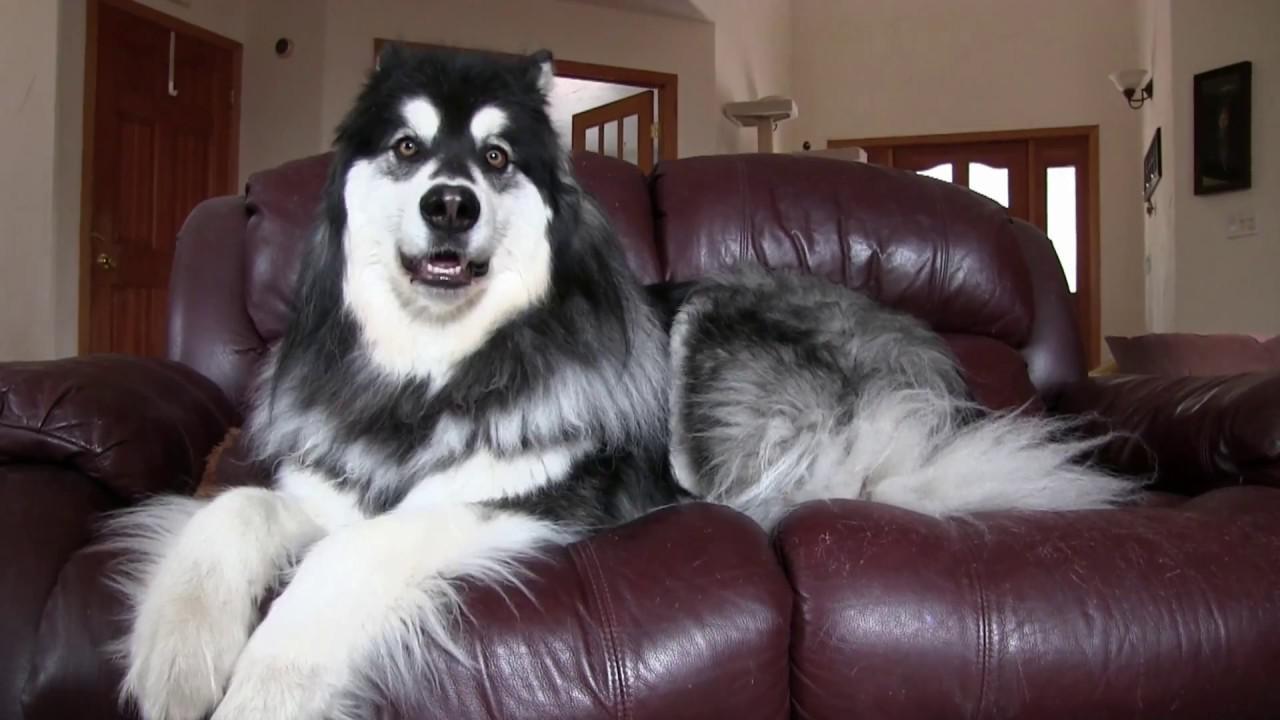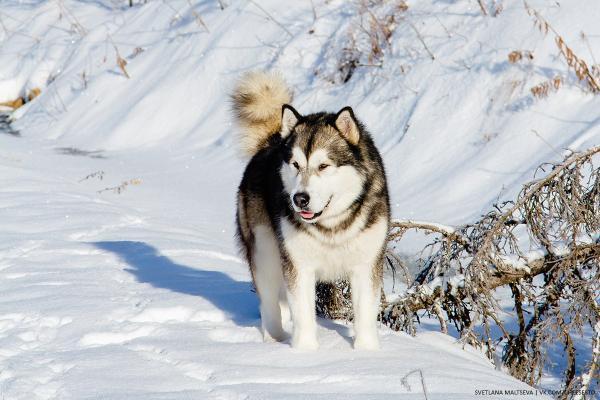The first image is the image on the left, the second image is the image on the right. Given the left and right images, does the statement "The left image shows a dog in some kind of reclining pose on a sofa, and the right image includes a husky dog outdoors on snow-covered ground." hold true? Answer yes or no. Yes. The first image is the image on the left, the second image is the image on the right. Given the left and right images, does the statement "There are two dogs outside." hold true? Answer yes or no. No. 